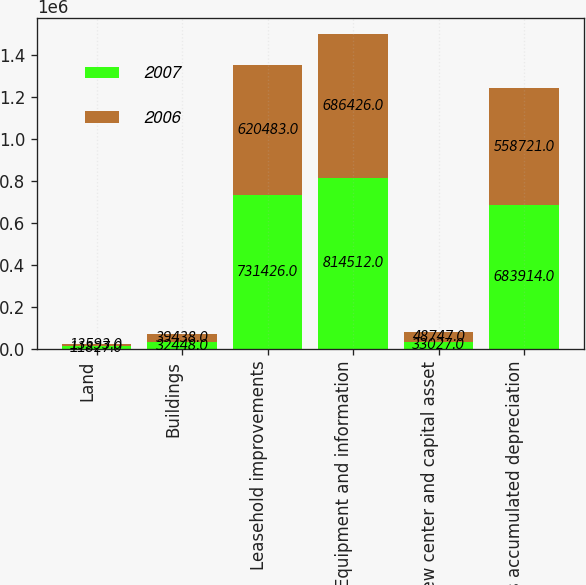Convert chart. <chart><loc_0><loc_0><loc_500><loc_500><stacked_bar_chart><ecel><fcel>Land<fcel>Buildings<fcel>Leasehold improvements<fcel>Equipment and information<fcel>New center and capital asset<fcel>Less accumulated depreciation<nl><fcel>2007<fcel>11827<fcel>32448<fcel>731426<fcel>814512<fcel>33027<fcel>683914<nl><fcel>2006<fcel>13593<fcel>39438<fcel>620483<fcel>686426<fcel>48747<fcel>558721<nl></chart> 